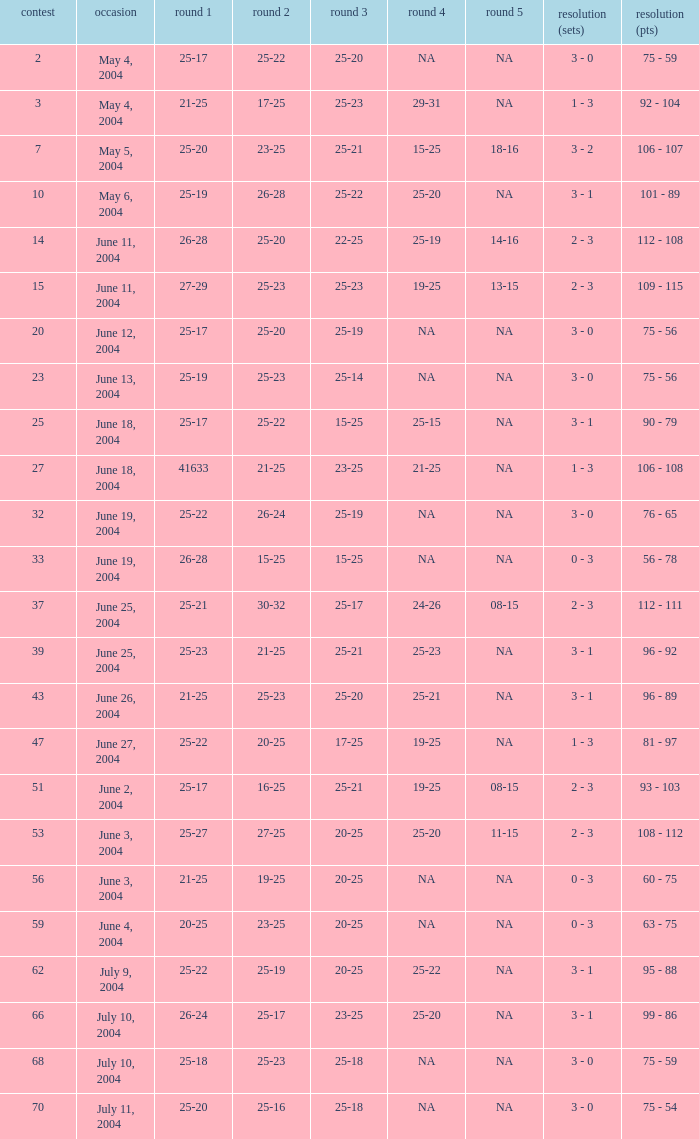What is the result of the game with a set 1 of 26-24? 99 - 86. 